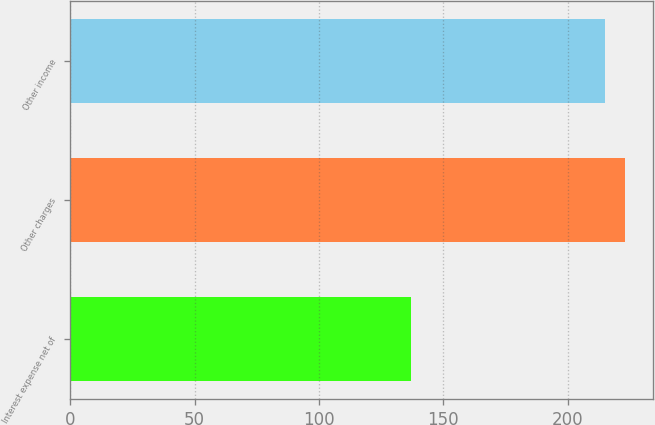<chart> <loc_0><loc_0><loc_500><loc_500><bar_chart><fcel>Interest expense net of<fcel>Other charges<fcel>Other income<nl><fcel>137<fcel>223<fcel>215<nl></chart> 